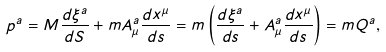<formula> <loc_0><loc_0><loc_500><loc_500>p ^ { a } = M \frac { d \xi ^ { a } } { d S } + m A ^ { a } _ { \mu } \frac { d x ^ { \mu } } { d s } = m \left ( \frac { d \xi ^ { a } } { d s } + A ^ { a } _ { \mu } \frac { d x ^ { \mu } } { d s } \right ) = m Q ^ { a } ,</formula> 